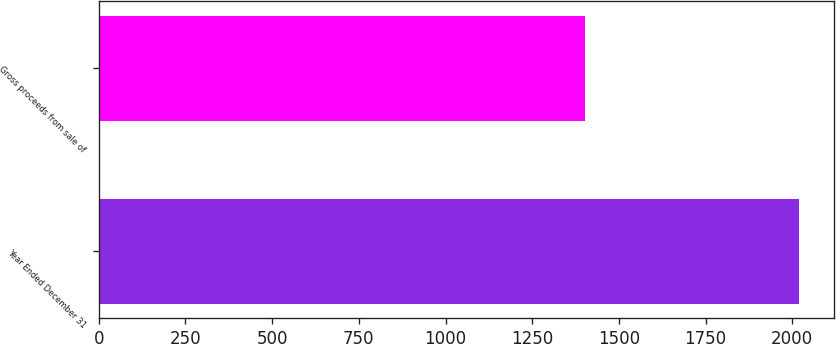<chart> <loc_0><loc_0><loc_500><loc_500><bar_chart><fcel>Year Ended December 31<fcel>Gross proceeds from sale of<nl><fcel>2018<fcel>1403<nl></chart> 